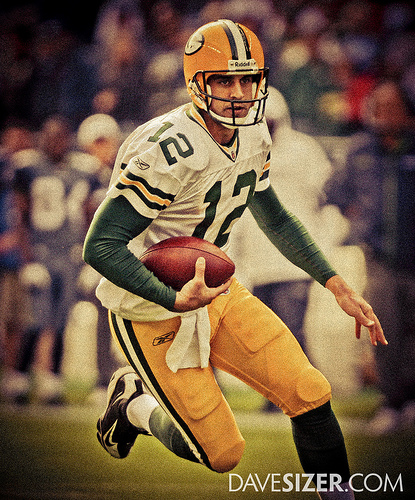<image>
Is the helmet above the rugby ball? Yes. The helmet is positioned above the rugby ball in the vertical space, higher up in the scene. 